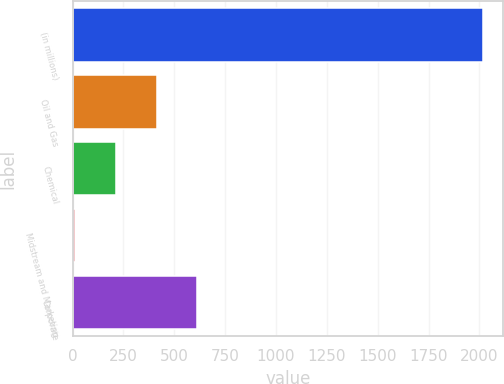Convert chart. <chart><loc_0><loc_0><loc_500><loc_500><bar_chart><fcel>(in millions)<fcel>Oil and Gas<fcel>Chemical<fcel>Midstream and Marketing<fcel>Corporate<nl><fcel>2015<fcel>413.4<fcel>213.2<fcel>13<fcel>613.6<nl></chart> 